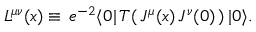Convert formula to latex. <formula><loc_0><loc_0><loc_500><loc_500>L ^ { \mu \nu } ( x ) \equiv \, e ^ { - 2 } \langle 0 | \, T ( \, J ^ { \mu } ( x ) \, J ^ { \nu } ( 0 ) \, ) \, | 0 \rangle .</formula> 